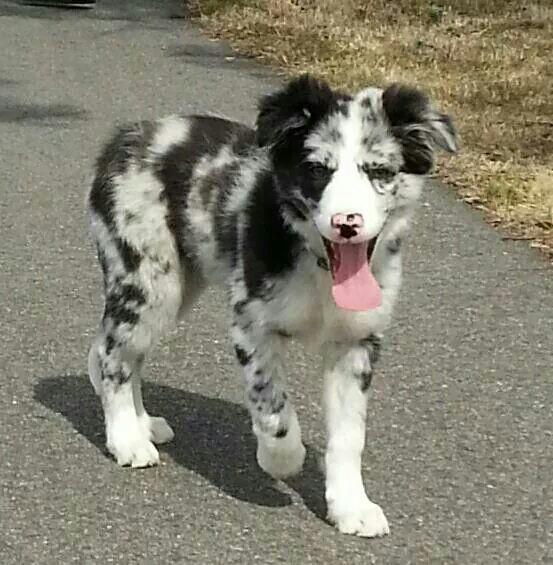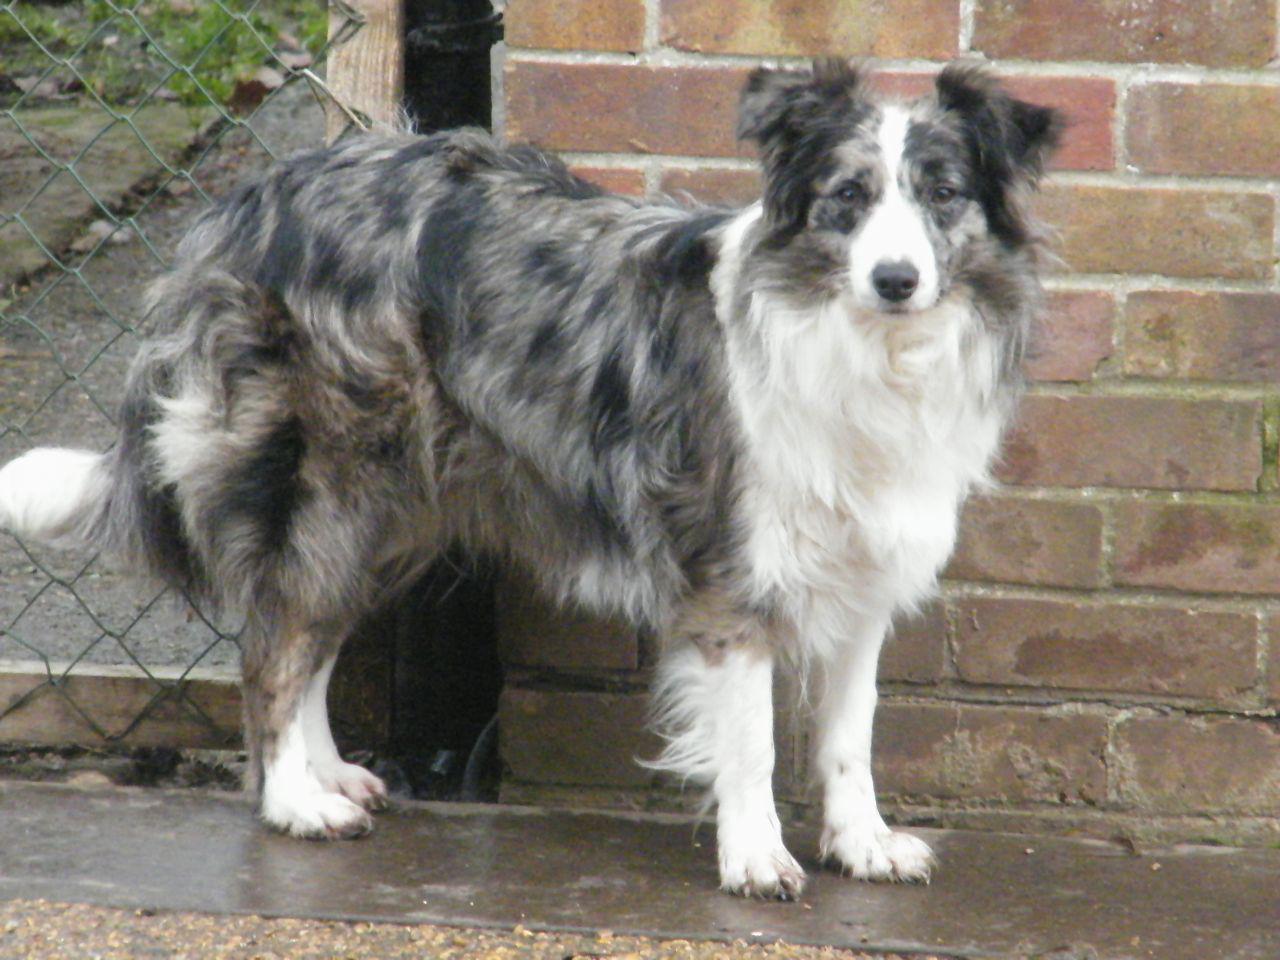The first image is the image on the left, the second image is the image on the right. For the images displayed, is the sentence "a dog is looking at the cameral with a brick wall behind it" factually correct? Answer yes or no. Yes. 